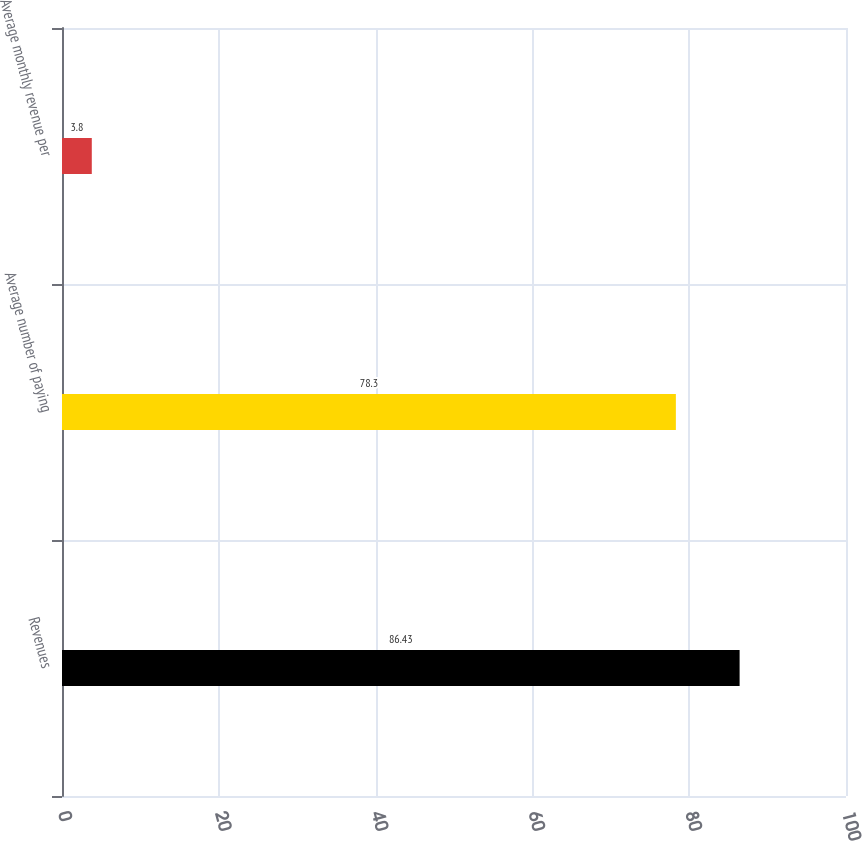Convert chart to OTSL. <chart><loc_0><loc_0><loc_500><loc_500><bar_chart><fcel>Revenues<fcel>Average number of paying<fcel>Average monthly revenue per<nl><fcel>86.43<fcel>78.3<fcel>3.8<nl></chart> 